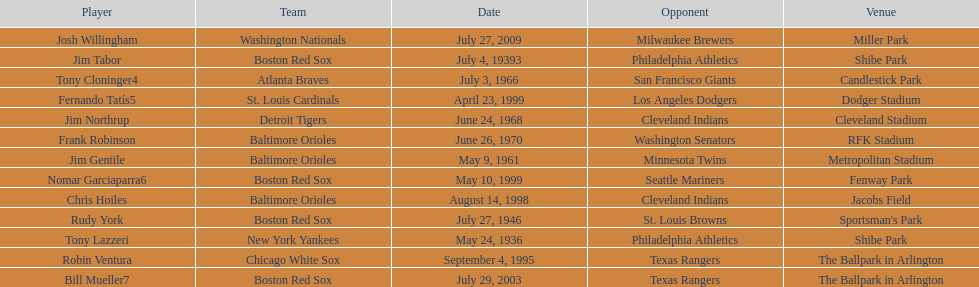Who is the first major league hitter to hit two grand slams in one game? Tony Lazzeri. 